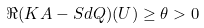<formula> <loc_0><loc_0><loc_500><loc_500>\Re ( K A - S d Q ) ( U ) \geq \theta > 0</formula> 